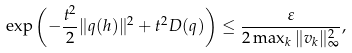Convert formula to latex. <formula><loc_0><loc_0><loc_500><loc_500>\exp \left ( - \frac { t ^ { 2 } } { 2 } \| q ( h ) \| ^ { 2 } + t ^ { 2 } D ( q ) \right ) \leq \frac { \varepsilon } { 2 \max _ { k } \| v _ { k } \| ^ { 2 } _ { \infty } } ,</formula> 